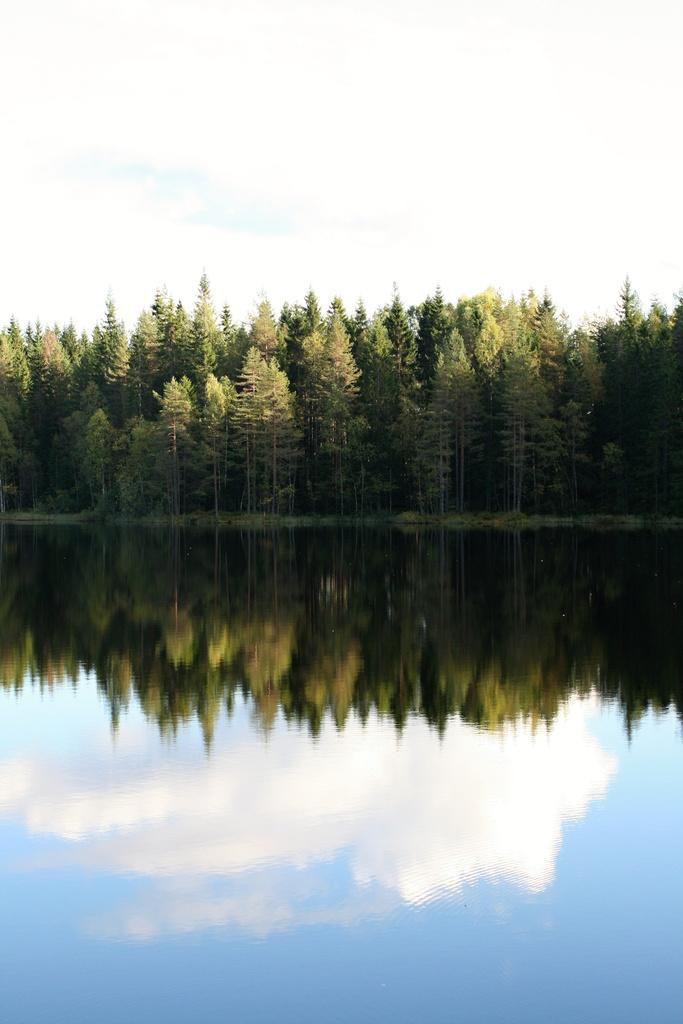What type of vegetation can be seen in the image? There are trees in the image. What natural element is also visible in the image? There is water visible in the image. What part of the natural environment is visible in the image? The sky is visible in the background of the image. Is there a prison visible in the image? No, there is no prison present in the image. Is anyone wearing a scarf in the image? There is no reference to a scarf or any clothing items in the image. 